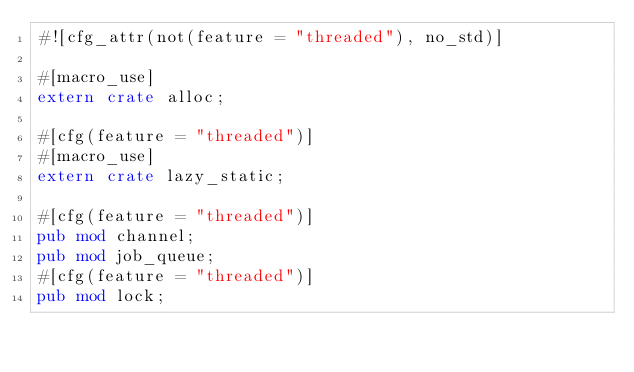Convert code to text. <code><loc_0><loc_0><loc_500><loc_500><_Rust_>#![cfg_attr(not(feature = "threaded"), no_std)]

#[macro_use]
extern crate alloc;

#[cfg(feature = "threaded")]
#[macro_use]
extern crate lazy_static;

#[cfg(feature = "threaded")]
pub mod channel;
pub mod job_queue;
#[cfg(feature = "threaded")]
pub mod lock;
</code> 